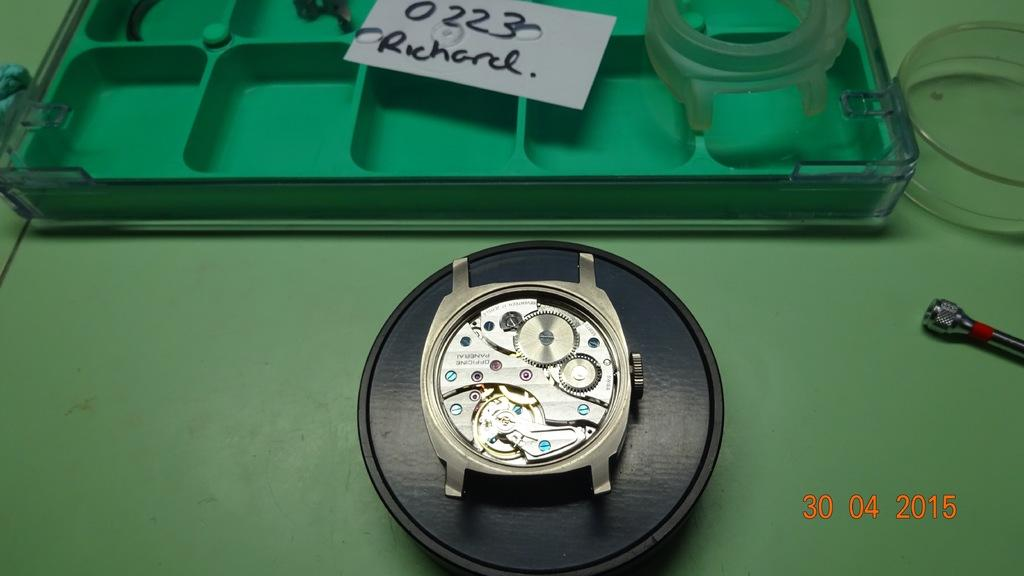Provide a one-sentence caption for the provided image. An incomplete watch sits on a table with a note addressed to Richard sitting above it. 